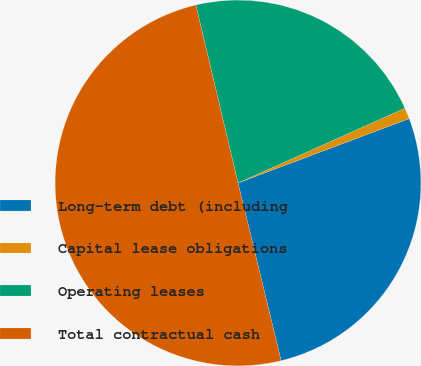<chart> <loc_0><loc_0><loc_500><loc_500><pie_chart><fcel>Long-term debt (including<fcel>Capital lease obligations<fcel>Operating leases<fcel>Total contractual cash<nl><fcel>26.93%<fcel>0.98%<fcel>22.0%<fcel>50.08%<nl></chart> 